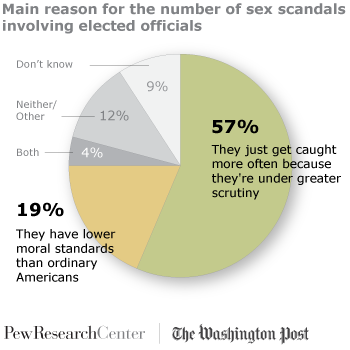Give some essential details in this illustration. The percentage of neither and both can be determined by considering the values of two sets such as [12, 4] and then applying the percentages to the elements in the sets. The color that represents "Don't know" is light grey. 